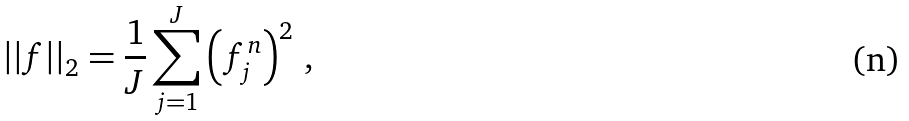Convert formula to latex. <formula><loc_0><loc_0><loc_500><loc_500>| | f | | _ { 2 } = \frac { 1 } { J } \sum _ { j = 1 } ^ { J } \left ( f _ { j } ^ { n } \right ) ^ { 2 } \, ,</formula> 